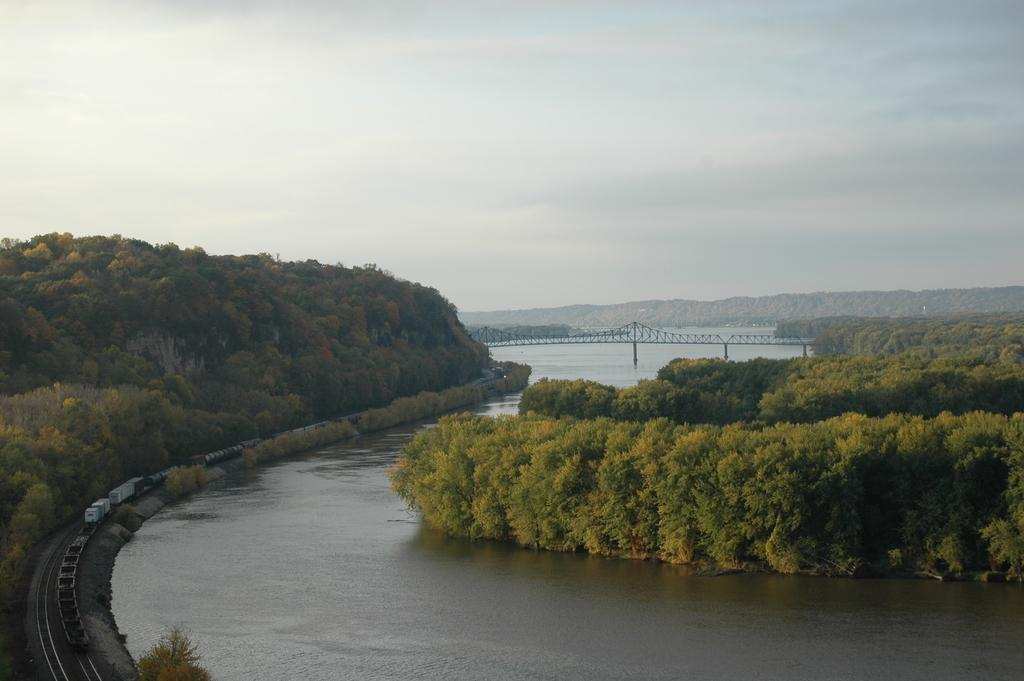What type of vegetation can be seen in the image? There are trees in the image. What type of structure is present in the image? There is a bridge in the image. What type of transportation infrastructure is visible in the image? There are rail tracks in the image. What is the main mode of transportation present in the image? There is a train in the image. What natural element is visible in the image? There is water visible in the image. What type of living organisms can be seen in the image? There are plants in the image. What is visible in the sky in the image? The sky is visible in the image, and there are clouds in the sky. What type of clam is being served on a cake for a birthday celebration in the image? There is no clam, cake, or birthday celebration present in the image. What type of creature is shown interacting with the train on the rail tracks in the image? There is no creature shown interacting with the train on the rail tracks in the image; only the train, bridge, trees, and other elements are present. 